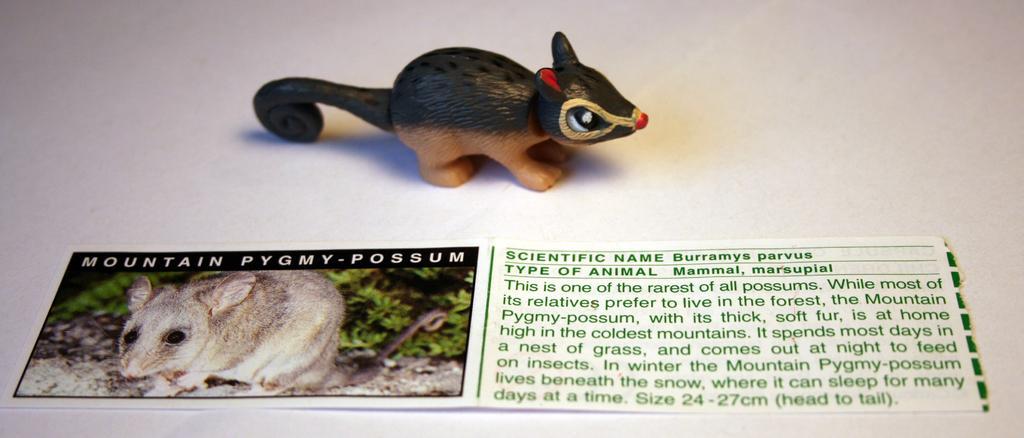Describe this image in one or two sentences. As we can see in the image there is a poster and toy rat. On poster there is something written. 